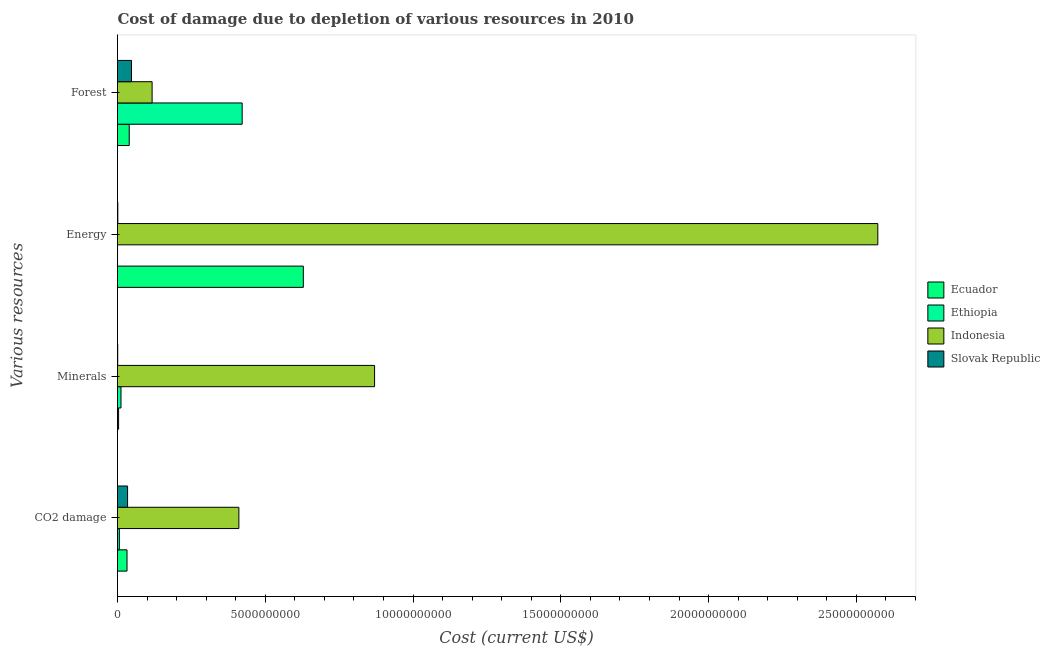How many different coloured bars are there?
Provide a succinct answer. 4. Are the number of bars on each tick of the Y-axis equal?
Ensure brevity in your answer.  Yes. How many bars are there on the 2nd tick from the top?
Ensure brevity in your answer.  4. What is the label of the 3rd group of bars from the top?
Keep it short and to the point. Minerals. What is the cost of damage due to depletion of coal in Slovak Republic?
Your response must be concise. 3.41e+08. Across all countries, what is the maximum cost of damage due to depletion of energy?
Offer a very short reply. 2.57e+1. Across all countries, what is the minimum cost of damage due to depletion of minerals?
Your answer should be very brief. 7.02e+06. In which country was the cost of damage due to depletion of energy minimum?
Your response must be concise. Ethiopia. What is the total cost of damage due to depletion of forests in the graph?
Your answer should be very brief. 6.26e+09. What is the difference between the cost of damage due to depletion of forests in Ethiopia and that in Ecuador?
Make the answer very short. 3.82e+09. What is the difference between the cost of damage due to depletion of minerals in Indonesia and the cost of damage due to depletion of energy in Ecuador?
Your answer should be very brief. 2.41e+09. What is the average cost of damage due to depletion of minerals per country?
Your answer should be very brief. 2.22e+09. What is the difference between the cost of damage due to depletion of minerals and cost of damage due to depletion of energy in Indonesia?
Offer a terse response. -1.70e+1. In how many countries, is the cost of damage due to depletion of energy greater than 6000000000 US$?
Ensure brevity in your answer.  2. What is the ratio of the cost of damage due to depletion of energy in Slovak Republic to that in Ethiopia?
Your answer should be very brief. 9.75. Is the cost of damage due to depletion of minerals in Ecuador less than that in Slovak Republic?
Provide a succinct answer. No. Is the difference between the cost of damage due to depletion of minerals in Slovak Republic and Indonesia greater than the difference between the cost of damage due to depletion of energy in Slovak Republic and Indonesia?
Your response must be concise. Yes. What is the difference between the highest and the second highest cost of damage due to depletion of coal?
Keep it short and to the point. 3.77e+09. What is the difference between the highest and the lowest cost of damage due to depletion of energy?
Your answer should be compact. 2.57e+1. In how many countries, is the cost of damage due to depletion of minerals greater than the average cost of damage due to depletion of minerals taken over all countries?
Your response must be concise. 1. What does the 1st bar from the top in Minerals represents?
Offer a very short reply. Slovak Republic. How many bars are there?
Make the answer very short. 16. Are all the bars in the graph horizontal?
Offer a very short reply. Yes. How many countries are there in the graph?
Keep it short and to the point. 4. What is the difference between two consecutive major ticks on the X-axis?
Your response must be concise. 5.00e+09. Are the values on the major ticks of X-axis written in scientific E-notation?
Give a very brief answer. No. Does the graph contain grids?
Keep it short and to the point. No. Where does the legend appear in the graph?
Provide a succinct answer. Center right. How many legend labels are there?
Give a very brief answer. 4. How are the legend labels stacked?
Make the answer very short. Vertical. What is the title of the graph?
Provide a succinct answer. Cost of damage due to depletion of various resources in 2010 . What is the label or title of the X-axis?
Offer a terse response. Cost (current US$). What is the label or title of the Y-axis?
Give a very brief answer. Various resources. What is the Cost (current US$) of Ecuador in CO2 damage?
Offer a very short reply. 3.22e+08. What is the Cost (current US$) of Ethiopia in CO2 damage?
Ensure brevity in your answer.  6.22e+07. What is the Cost (current US$) in Indonesia in CO2 damage?
Provide a short and direct response. 4.11e+09. What is the Cost (current US$) in Slovak Republic in CO2 damage?
Your response must be concise. 3.41e+08. What is the Cost (current US$) in Ecuador in Minerals?
Your answer should be compact. 3.66e+07. What is the Cost (current US$) in Ethiopia in Minerals?
Ensure brevity in your answer.  1.18e+08. What is the Cost (current US$) of Indonesia in Minerals?
Ensure brevity in your answer.  8.70e+09. What is the Cost (current US$) of Slovak Republic in Minerals?
Ensure brevity in your answer.  7.02e+06. What is the Cost (current US$) in Ecuador in Energy?
Ensure brevity in your answer.  6.29e+09. What is the Cost (current US$) in Ethiopia in Energy?
Your response must be concise. 1.04e+06. What is the Cost (current US$) in Indonesia in Energy?
Offer a terse response. 2.57e+1. What is the Cost (current US$) of Slovak Republic in Energy?
Give a very brief answer. 1.02e+07. What is the Cost (current US$) in Ecuador in Forest?
Provide a succinct answer. 3.96e+08. What is the Cost (current US$) of Ethiopia in Forest?
Offer a very short reply. 4.22e+09. What is the Cost (current US$) of Indonesia in Forest?
Keep it short and to the point. 1.17e+09. What is the Cost (current US$) in Slovak Republic in Forest?
Provide a succinct answer. 4.73e+08. Across all Various resources, what is the maximum Cost (current US$) of Ecuador?
Provide a short and direct response. 6.29e+09. Across all Various resources, what is the maximum Cost (current US$) in Ethiopia?
Provide a short and direct response. 4.22e+09. Across all Various resources, what is the maximum Cost (current US$) of Indonesia?
Offer a very short reply. 2.57e+1. Across all Various resources, what is the maximum Cost (current US$) in Slovak Republic?
Offer a terse response. 4.73e+08. Across all Various resources, what is the minimum Cost (current US$) in Ecuador?
Your answer should be very brief. 3.66e+07. Across all Various resources, what is the minimum Cost (current US$) in Ethiopia?
Your answer should be very brief. 1.04e+06. Across all Various resources, what is the minimum Cost (current US$) in Indonesia?
Your response must be concise. 1.17e+09. Across all Various resources, what is the minimum Cost (current US$) in Slovak Republic?
Offer a terse response. 7.02e+06. What is the total Cost (current US$) in Ecuador in the graph?
Offer a terse response. 7.04e+09. What is the total Cost (current US$) in Ethiopia in the graph?
Offer a terse response. 4.40e+09. What is the total Cost (current US$) in Indonesia in the graph?
Provide a succinct answer. 3.97e+1. What is the total Cost (current US$) of Slovak Republic in the graph?
Your answer should be very brief. 8.30e+08. What is the difference between the Cost (current US$) in Ecuador in CO2 damage and that in Minerals?
Your answer should be compact. 2.85e+08. What is the difference between the Cost (current US$) in Ethiopia in CO2 damage and that in Minerals?
Your answer should be very brief. -5.56e+07. What is the difference between the Cost (current US$) in Indonesia in CO2 damage and that in Minerals?
Provide a succinct answer. -4.59e+09. What is the difference between the Cost (current US$) in Slovak Republic in CO2 damage and that in Minerals?
Offer a terse response. 3.34e+08. What is the difference between the Cost (current US$) of Ecuador in CO2 damage and that in Energy?
Make the answer very short. -5.97e+09. What is the difference between the Cost (current US$) in Ethiopia in CO2 damage and that in Energy?
Offer a terse response. 6.12e+07. What is the difference between the Cost (current US$) in Indonesia in CO2 damage and that in Energy?
Provide a short and direct response. -2.16e+1. What is the difference between the Cost (current US$) of Slovak Republic in CO2 damage and that in Energy?
Your response must be concise. 3.30e+08. What is the difference between the Cost (current US$) of Ecuador in CO2 damage and that in Forest?
Keep it short and to the point. -7.45e+07. What is the difference between the Cost (current US$) of Ethiopia in CO2 damage and that in Forest?
Keep it short and to the point. -4.16e+09. What is the difference between the Cost (current US$) of Indonesia in CO2 damage and that in Forest?
Your response must be concise. 2.94e+09. What is the difference between the Cost (current US$) of Slovak Republic in CO2 damage and that in Forest?
Make the answer very short. -1.32e+08. What is the difference between the Cost (current US$) in Ecuador in Minerals and that in Energy?
Give a very brief answer. -6.25e+09. What is the difference between the Cost (current US$) in Ethiopia in Minerals and that in Energy?
Offer a terse response. 1.17e+08. What is the difference between the Cost (current US$) in Indonesia in Minerals and that in Energy?
Offer a terse response. -1.70e+1. What is the difference between the Cost (current US$) in Slovak Republic in Minerals and that in Energy?
Give a very brief answer. -3.16e+06. What is the difference between the Cost (current US$) in Ecuador in Minerals and that in Forest?
Your answer should be very brief. -3.60e+08. What is the difference between the Cost (current US$) in Ethiopia in Minerals and that in Forest?
Offer a very short reply. -4.10e+09. What is the difference between the Cost (current US$) of Indonesia in Minerals and that in Forest?
Ensure brevity in your answer.  7.53e+09. What is the difference between the Cost (current US$) in Slovak Republic in Minerals and that in Forest?
Keep it short and to the point. -4.66e+08. What is the difference between the Cost (current US$) in Ecuador in Energy and that in Forest?
Offer a very short reply. 5.89e+09. What is the difference between the Cost (current US$) of Ethiopia in Energy and that in Forest?
Ensure brevity in your answer.  -4.22e+09. What is the difference between the Cost (current US$) of Indonesia in Energy and that in Forest?
Provide a succinct answer. 2.46e+1. What is the difference between the Cost (current US$) of Slovak Republic in Energy and that in Forest?
Your answer should be very brief. -4.62e+08. What is the difference between the Cost (current US$) of Ecuador in CO2 damage and the Cost (current US$) of Ethiopia in Minerals?
Ensure brevity in your answer.  2.04e+08. What is the difference between the Cost (current US$) in Ecuador in CO2 damage and the Cost (current US$) in Indonesia in Minerals?
Make the answer very short. -8.38e+09. What is the difference between the Cost (current US$) of Ecuador in CO2 damage and the Cost (current US$) of Slovak Republic in Minerals?
Your response must be concise. 3.15e+08. What is the difference between the Cost (current US$) of Ethiopia in CO2 damage and the Cost (current US$) of Indonesia in Minerals?
Offer a very short reply. -8.64e+09. What is the difference between the Cost (current US$) of Ethiopia in CO2 damage and the Cost (current US$) of Slovak Republic in Minerals?
Ensure brevity in your answer.  5.52e+07. What is the difference between the Cost (current US$) in Indonesia in CO2 damage and the Cost (current US$) in Slovak Republic in Minerals?
Ensure brevity in your answer.  4.10e+09. What is the difference between the Cost (current US$) in Ecuador in CO2 damage and the Cost (current US$) in Ethiopia in Energy?
Your answer should be very brief. 3.21e+08. What is the difference between the Cost (current US$) of Ecuador in CO2 damage and the Cost (current US$) of Indonesia in Energy?
Offer a very short reply. -2.54e+1. What is the difference between the Cost (current US$) of Ecuador in CO2 damage and the Cost (current US$) of Slovak Republic in Energy?
Make the answer very short. 3.12e+08. What is the difference between the Cost (current US$) in Ethiopia in CO2 damage and the Cost (current US$) in Indonesia in Energy?
Provide a short and direct response. -2.57e+1. What is the difference between the Cost (current US$) in Ethiopia in CO2 damage and the Cost (current US$) in Slovak Republic in Energy?
Provide a short and direct response. 5.20e+07. What is the difference between the Cost (current US$) of Indonesia in CO2 damage and the Cost (current US$) of Slovak Republic in Energy?
Offer a very short reply. 4.10e+09. What is the difference between the Cost (current US$) of Ecuador in CO2 damage and the Cost (current US$) of Ethiopia in Forest?
Offer a terse response. -3.90e+09. What is the difference between the Cost (current US$) in Ecuador in CO2 damage and the Cost (current US$) in Indonesia in Forest?
Your answer should be compact. -8.49e+08. What is the difference between the Cost (current US$) in Ecuador in CO2 damage and the Cost (current US$) in Slovak Republic in Forest?
Provide a short and direct response. -1.51e+08. What is the difference between the Cost (current US$) in Ethiopia in CO2 damage and the Cost (current US$) in Indonesia in Forest?
Make the answer very short. -1.11e+09. What is the difference between the Cost (current US$) in Ethiopia in CO2 damage and the Cost (current US$) in Slovak Republic in Forest?
Your response must be concise. -4.10e+08. What is the difference between the Cost (current US$) of Indonesia in CO2 damage and the Cost (current US$) of Slovak Republic in Forest?
Your answer should be very brief. 3.63e+09. What is the difference between the Cost (current US$) of Ecuador in Minerals and the Cost (current US$) of Ethiopia in Energy?
Your answer should be compact. 3.55e+07. What is the difference between the Cost (current US$) in Ecuador in Minerals and the Cost (current US$) in Indonesia in Energy?
Offer a very short reply. -2.57e+1. What is the difference between the Cost (current US$) of Ecuador in Minerals and the Cost (current US$) of Slovak Republic in Energy?
Your answer should be compact. 2.64e+07. What is the difference between the Cost (current US$) of Ethiopia in Minerals and the Cost (current US$) of Indonesia in Energy?
Your answer should be very brief. -2.56e+1. What is the difference between the Cost (current US$) in Ethiopia in Minerals and the Cost (current US$) in Slovak Republic in Energy?
Your answer should be compact. 1.08e+08. What is the difference between the Cost (current US$) in Indonesia in Minerals and the Cost (current US$) in Slovak Republic in Energy?
Provide a short and direct response. 8.69e+09. What is the difference between the Cost (current US$) in Ecuador in Minerals and the Cost (current US$) in Ethiopia in Forest?
Provide a short and direct response. -4.18e+09. What is the difference between the Cost (current US$) in Ecuador in Minerals and the Cost (current US$) in Indonesia in Forest?
Ensure brevity in your answer.  -1.13e+09. What is the difference between the Cost (current US$) of Ecuador in Minerals and the Cost (current US$) of Slovak Republic in Forest?
Your answer should be very brief. -4.36e+08. What is the difference between the Cost (current US$) in Ethiopia in Minerals and the Cost (current US$) in Indonesia in Forest?
Your answer should be very brief. -1.05e+09. What is the difference between the Cost (current US$) in Ethiopia in Minerals and the Cost (current US$) in Slovak Republic in Forest?
Offer a terse response. -3.55e+08. What is the difference between the Cost (current US$) of Indonesia in Minerals and the Cost (current US$) of Slovak Republic in Forest?
Give a very brief answer. 8.23e+09. What is the difference between the Cost (current US$) in Ecuador in Energy and the Cost (current US$) in Ethiopia in Forest?
Provide a short and direct response. 2.07e+09. What is the difference between the Cost (current US$) in Ecuador in Energy and the Cost (current US$) in Indonesia in Forest?
Offer a very short reply. 5.12e+09. What is the difference between the Cost (current US$) in Ecuador in Energy and the Cost (current US$) in Slovak Republic in Forest?
Keep it short and to the point. 5.82e+09. What is the difference between the Cost (current US$) in Ethiopia in Energy and the Cost (current US$) in Indonesia in Forest?
Your answer should be very brief. -1.17e+09. What is the difference between the Cost (current US$) of Ethiopia in Energy and the Cost (current US$) of Slovak Republic in Forest?
Give a very brief answer. -4.72e+08. What is the difference between the Cost (current US$) in Indonesia in Energy and the Cost (current US$) in Slovak Republic in Forest?
Give a very brief answer. 2.53e+1. What is the average Cost (current US$) in Ecuador per Various resources?
Your answer should be very brief. 1.76e+09. What is the average Cost (current US$) of Ethiopia per Various resources?
Ensure brevity in your answer.  1.10e+09. What is the average Cost (current US$) in Indonesia per Various resources?
Provide a succinct answer. 9.93e+09. What is the average Cost (current US$) in Slovak Republic per Various resources?
Your answer should be compact. 2.08e+08. What is the difference between the Cost (current US$) of Ecuador and Cost (current US$) of Ethiopia in CO2 damage?
Keep it short and to the point. 2.60e+08. What is the difference between the Cost (current US$) of Ecuador and Cost (current US$) of Indonesia in CO2 damage?
Your answer should be very brief. -3.78e+09. What is the difference between the Cost (current US$) of Ecuador and Cost (current US$) of Slovak Republic in CO2 damage?
Provide a succinct answer. -1.87e+07. What is the difference between the Cost (current US$) of Ethiopia and Cost (current US$) of Indonesia in CO2 damage?
Provide a succinct answer. -4.04e+09. What is the difference between the Cost (current US$) in Ethiopia and Cost (current US$) in Slovak Republic in CO2 damage?
Provide a succinct answer. -2.78e+08. What is the difference between the Cost (current US$) of Indonesia and Cost (current US$) of Slovak Republic in CO2 damage?
Offer a very short reply. 3.77e+09. What is the difference between the Cost (current US$) in Ecuador and Cost (current US$) in Ethiopia in Minerals?
Your response must be concise. -8.12e+07. What is the difference between the Cost (current US$) in Ecuador and Cost (current US$) in Indonesia in Minerals?
Your response must be concise. -8.66e+09. What is the difference between the Cost (current US$) in Ecuador and Cost (current US$) in Slovak Republic in Minerals?
Make the answer very short. 2.96e+07. What is the difference between the Cost (current US$) in Ethiopia and Cost (current US$) in Indonesia in Minerals?
Your answer should be very brief. -8.58e+09. What is the difference between the Cost (current US$) of Ethiopia and Cost (current US$) of Slovak Republic in Minerals?
Your response must be concise. 1.11e+08. What is the difference between the Cost (current US$) in Indonesia and Cost (current US$) in Slovak Republic in Minerals?
Your response must be concise. 8.69e+09. What is the difference between the Cost (current US$) of Ecuador and Cost (current US$) of Ethiopia in Energy?
Keep it short and to the point. 6.29e+09. What is the difference between the Cost (current US$) in Ecuador and Cost (current US$) in Indonesia in Energy?
Give a very brief answer. -1.94e+1. What is the difference between the Cost (current US$) of Ecuador and Cost (current US$) of Slovak Republic in Energy?
Keep it short and to the point. 6.28e+09. What is the difference between the Cost (current US$) in Ethiopia and Cost (current US$) in Indonesia in Energy?
Provide a succinct answer. -2.57e+1. What is the difference between the Cost (current US$) in Ethiopia and Cost (current US$) in Slovak Republic in Energy?
Offer a terse response. -9.14e+06. What is the difference between the Cost (current US$) in Indonesia and Cost (current US$) in Slovak Republic in Energy?
Provide a succinct answer. 2.57e+1. What is the difference between the Cost (current US$) in Ecuador and Cost (current US$) in Ethiopia in Forest?
Provide a succinct answer. -3.82e+09. What is the difference between the Cost (current US$) in Ecuador and Cost (current US$) in Indonesia in Forest?
Provide a succinct answer. -7.74e+08. What is the difference between the Cost (current US$) of Ecuador and Cost (current US$) of Slovak Republic in Forest?
Ensure brevity in your answer.  -7.63e+07. What is the difference between the Cost (current US$) of Ethiopia and Cost (current US$) of Indonesia in Forest?
Keep it short and to the point. 3.05e+09. What is the difference between the Cost (current US$) in Ethiopia and Cost (current US$) in Slovak Republic in Forest?
Offer a terse response. 3.75e+09. What is the difference between the Cost (current US$) of Indonesia and Cost (current US$) of Slovak Republic in Forest?
Your answer should be compact. 6.98e+08. What is the ratio of the Cost (current US$) in Ecuador in CO2 damage to that in Minerals?
Ensure brevity in your answer.  8.8. What is the ratio of the Cost (current US$) in Ethiopia in CO2 damage to that in Minerals?
Ensure brevity in your answer.  0.53. What is the ratio of the Cost (current US$) of Indonesia in CO2 damage to that in Minerals?
Offer a very short reply. 0.47. What is the ratio of the Cost (current US$) of Slovak Republic in CO2 damage to that in Minerals?
Give a very brief answer. 48.5. What is the ratio of the Cost (current US$) in Ecuador in CO2 damage to that in Energy?
Ensure brevity in your answer.  0.05. What is the ratio of the Cost (current US$) in Ethiopia in CO2 damage to that in Energy?
Your answer should be very brief. 59.54. What is the ratio of the Cost (current US$) in Indonesia in CO2 damage to that in Energy?
Make the answer very short. 0.16. What is the ratio of the Cost (current US$) in Slovak Republic in CO2 damage to that in Energy?
Offer a very short reply. 33.45. What is the ratio of the Cost (current US$) of Ecuador in CO2 damage to that in Forest?
Your answer should be compact. 0.81. What is the ratio of the Cost (current US$) of Ethiopia in CO2 damage to that in Forest?
Your response must be concise. 0.01. What is the ratio of the Cost (current US$) in Indonesia in CO2 damage to that in Forest?
Offer a very short reply. 3.51. What is the ratio of the Cost (current US$) of Slovak Republic in CO2 damage to that in Forest?
Your answer should be very brief. 0.72. What is the ratio of the Cost (current US$) of Ecuador in Minerals to that in Energy?
Make the answer very short. 0.01. What is the ratio of the Cost (current US$) in Ethiopia in Minerals to that in Energy?
Your answer should be very brief. 112.74. What is the ratio of the Cost (current US$) of Indonesia in Minerals to that in Energy?
Make the answer very short. 0.34. What is the ratio of the Cost (current US$) of Slovak Republic in Minerals to that in Energy?
Your answer should be compact. 0.69. What is the ratio of the Cost (current US$) in Ecuador in Minerals to that in Forest?
Offer a very short reply. 0.09. What is the ratio of the Cost (current US$) of Ethiopia in Minerals to that in Forest?
Give a very brief answer. 0.03. What is the ratio of the Cost (current US$) in Indonesia in Minerals to that in Forest?
Ensure brevity in your answer.  7.43. What is the ratio of the Cost (current US$) of Slovak Republic in Minerals to that in Forest?
Provide a short and direct response. 0.01. What is the ratio of the Cost (current US$) of Ecuador in Energy to that in Forest?
Your answer should be very brief. 15.86. What is the ratio of the Cost (current US$) of Indonesia in Energy to that in Forest?
Offer a very short reply. 21.97. What is the ratio of the Cost (current US$) of Slovak Republic in Energy to that in Forest?
Offer a terse response. 0.02. What is the difference between the highest and the second highest Cost (current US$) in Ecuador?
Make the answer very short. 5.89e+09. What is the difference between the highest and the second highest Cost (current US$) of Ethiopia?
Offer a terse response. 4.10e+09. What is the difference between the highest and the second highest Cost (current US$) in Indonesia?
Offer a terse response. 1.70e+1. What is the difference between the highest and the second highest Cost (current US$) in Slovak Republic?
Ensure brevity in your answer.  1.32e+08. What is the difference between the highest and the lowest Cost (current US$) of Ecuador?
Keep it short and to the point. 6.25e+09. What is the difference between the highest and the lowest Cost (current US$) in Ethiopia?
Your response must be concise. 4.22e+09. What is the difference between the highest and the lowest Cost (current US$) of Indonesia?
Your answer should be very brief. 2.46e+1. What is the difference between the highest and the lowest Cost (current US$) in Slovak Republic?
Your answer should be compact. 4.66e+08. 